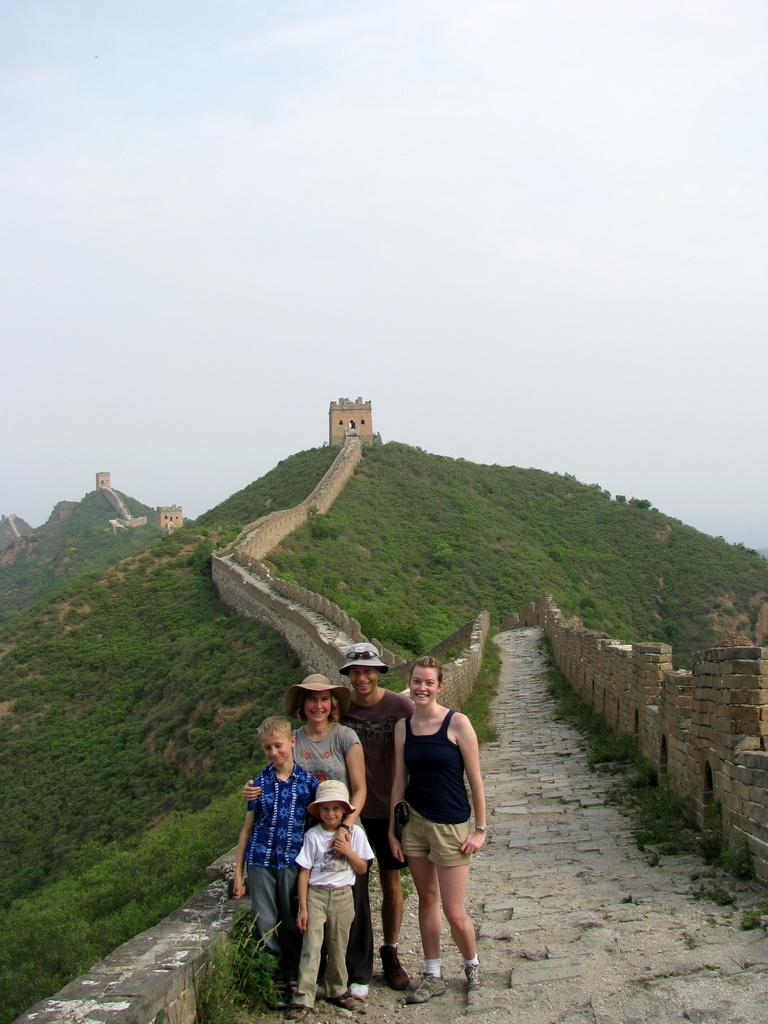What is happening on the bridge in the image? There are people on the bridge in the image. Can you describe the attire of some of the people on the bridge? Some of the people on the bridge are wearing hats. What can be seen in the background of the image? There are forts visible on the hills in the background of the image. What is visible at the top of the image? The sky is visible at the top of the image. What type of bomb is being dropped from the airplane in the image? There is no airplane or bomb present in the image; it features people on a bridge with forts visible in the background. 